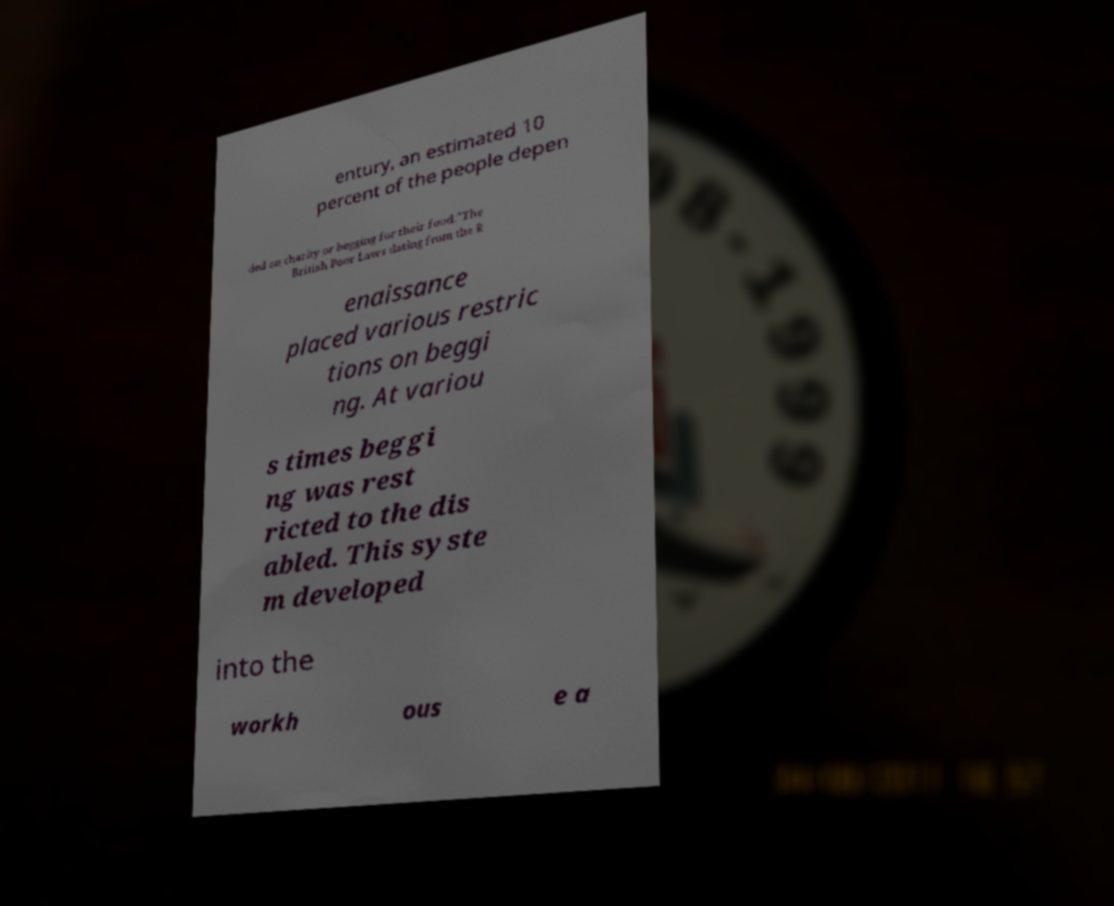Can you accurately transcribe the text from the provided image for me? entury, an estimated 10 percent of the people depen ded on charity or begging for their food."The British Poor Laws dating from the R enaissance placed various restric tions on beggi ng. At variou s times beggi ng was rest ricted to the dis abled. This syste m developed into the workh ous e a 